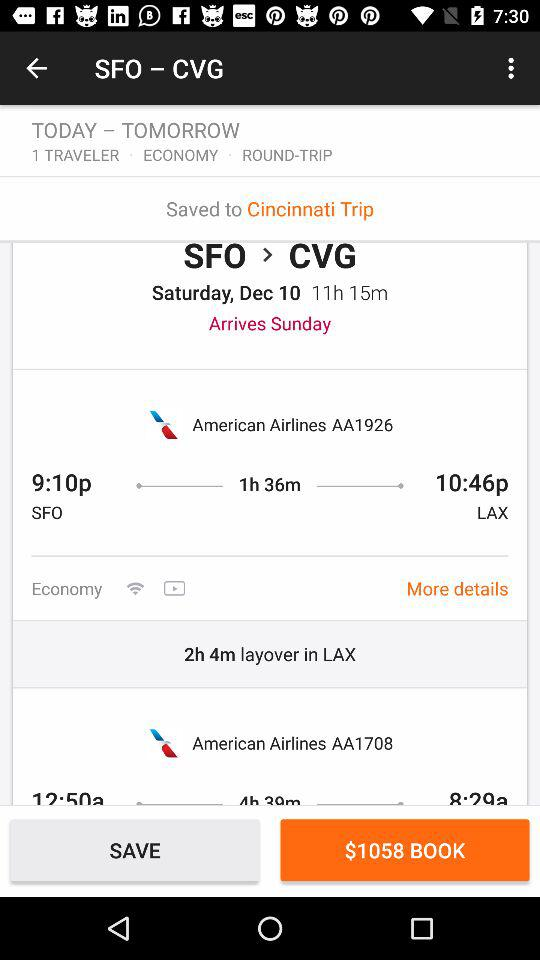What is the class of the trip? The class of the trip is economy. 